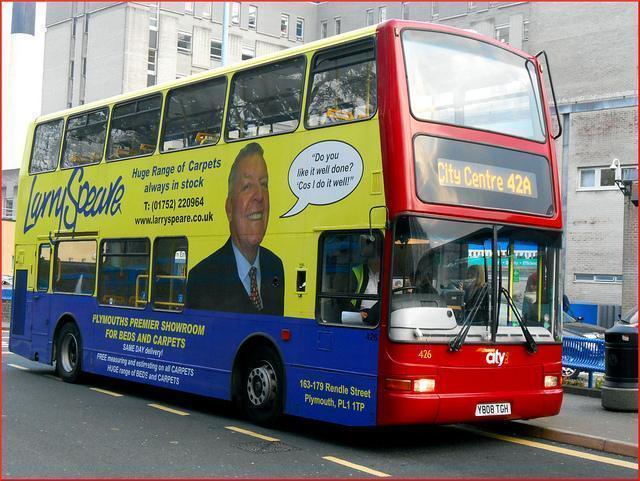What brand of bus manufacturer is displayed on the bus?
From the following set of four choices, select the accurate answer to respond to the question.
Options: Yellowbird, grayhound, good sam, city. City. 